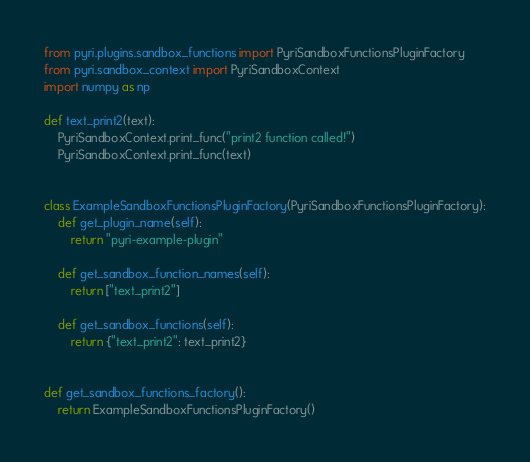<code> <loc_0><loc_0><loc_500><loc_500><_Python_>from pyri.plugins.sandbox_functions import PyriSandboxFunctionsPluginFactory
from pyri.sandbox_context import PyriSandboxContext
import numpy as np

def text_print2(text):
    PyriSandboxContext.print_func("print2 function called!")
    PyriSandboxContext.print_func(text)


class ExampleSandboxFunctionsPluginFactory(PyriSandboxFunctionsPluginFactory):
    def get_plugin_name(self):
        return "pyri-example-plugin"

    def get_sandbox_function_names(self):
        return ["text_print2"]

    def get_sandbox_functions(self):
        return {"text_print2": text_print2}


def get_sandbox_functions_factory():
    return ExampleSandboxFunctionsPluginFactory()</code> 